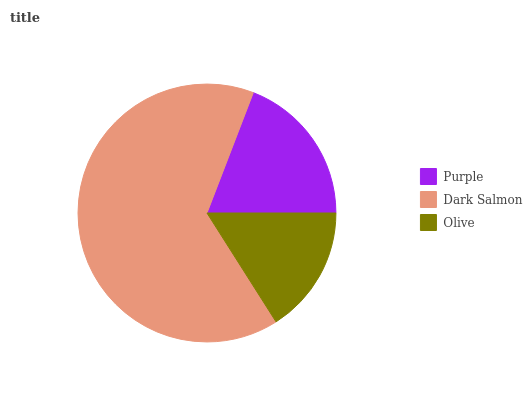Is Olive the minimum?
Answer yes or no. Yes. Is Dark Salmon the maximum?
Answer yes or no. Yes. Is Dark Salmon the minimum?
Answer yes or no. No. Is Olive the maximum?
Answer yes or no. No. Is Dark Salmon greater than Olive?
Answer yes or no. Yes. Is Olive less than Dark Salmon?
Answer yes or no. Yes. Is Olive greater than Dark Salmon?
Answer yes or no. No. Is Dark Salmon less than Olive?
Answer yes or no. No. Is Purple the high median?
Answer yes or no. Yes. Is Purple the low median?
Answer yes or no. Yes. Is Olive the high median?
Answer yes or no. No. Is Dark Salmon the low median?
Answer yes or no. No. 